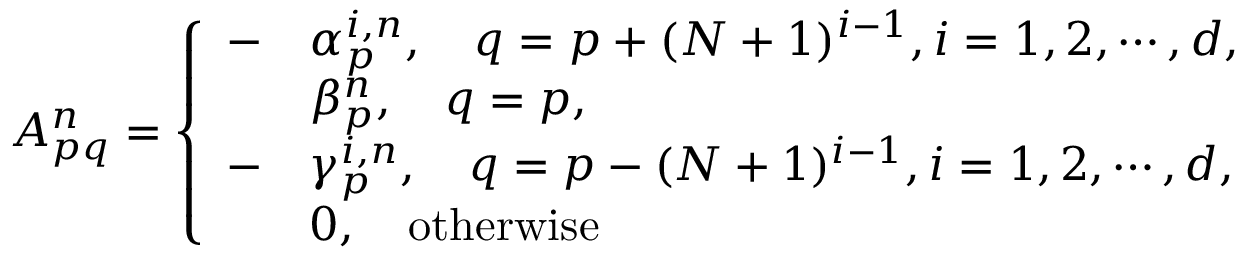Convert formula to latex. <formula><loc_0><loc_0><loc_500><loc_500>\begin{array} { r } { A _ { p q } ^ { n } = \left \{ \begin{array} { l l } { - } & { \alpha _ { p } ^ { i , n } , \quad q = p + ( N + 1 ) ^ { i - 1 } , i = 1 , 2 , \cdots , d , } \\ & { \beta _ { p } ^ { n } , \quad q = p , } \\ { - } & { \gamma _ { p } ^ { i , n } , \quad q = p - ( N + 1 ) ^ { i - 1 } , i = 1 , 2 , \cdots , d , } \\ & { 0 , \quad o t h e r w i s e } \end{array} } \end{array}</formula> 